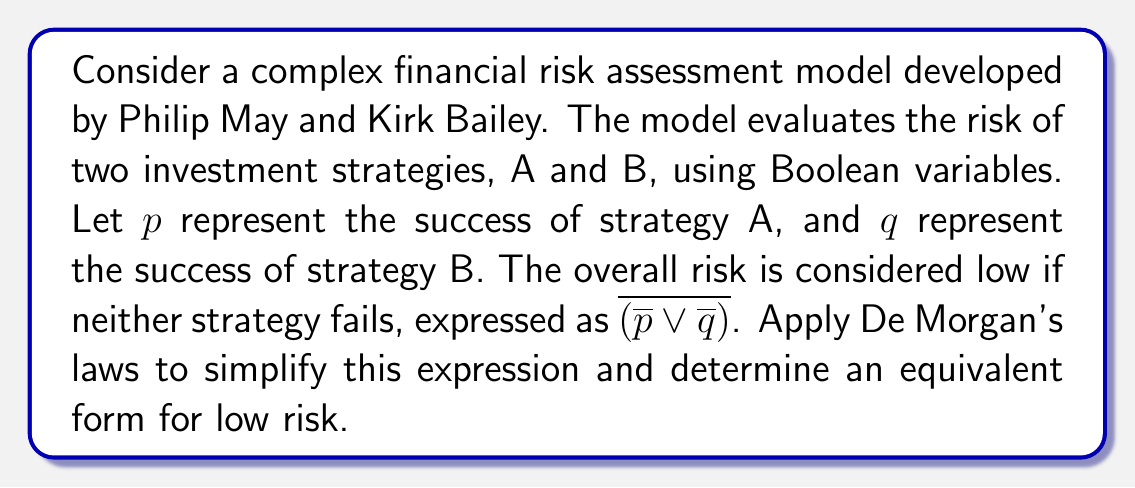Could you help me with this problem? To simplify the expression $\overline{(\overline{p} \lor \overline{q})}$ using De Morgan's laws, we'll follow these steps:

1) First, recall De Morgan's laws:
   $$\overline{(x \lor y)} = \overline{x} \land \overline{y}$$
   $$\overline{(x \land y)} = \overline{x} \lor \overline{y}$$

2) In our case, we have $\overline{(\overline{p} \lor \overline{q})}$. This matches the form of the first law, where $x = \overline{p}$ and $y = \overline{q}$.

3) Applying the law:
   $$\overline{(\overline{p} \lor \overline{q})} = \overline{\overline{p}} \land \overline{\overline{q}}$$

4) Now, we can simplify further using the double negation rule: $\overline{\overline{x}} = x$

5) Applying this to both terms:
   $$\overline{\overline{p}} \land \overline{\overline{q}} = p \land q$$

Therefore, the simplified expression for low risk is $p \land q$, which means both strategy A and strategy B succeed.
Answer: $p \land q$ 